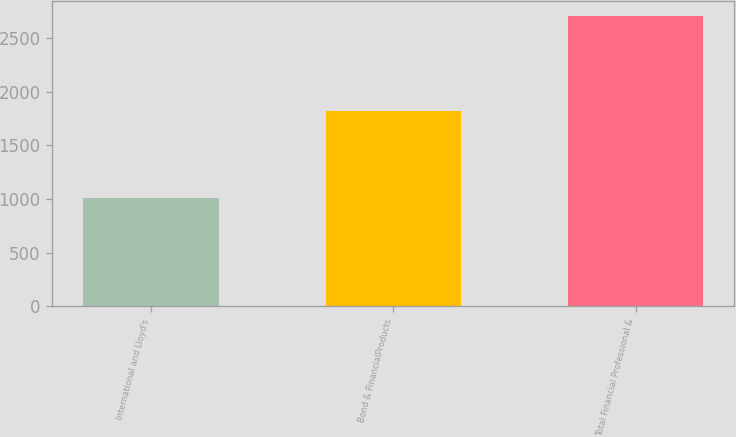Convert chart. <chart><loc_0><loc_0><loc_500><loc_500><bar_chart><fcel>International and Lloyd's<fcel>Bond & FinancialProducts<fcel>Total Financial Professional &<nl><fcel>1011<fcel>1819<fcel>2708<nl></chart> 